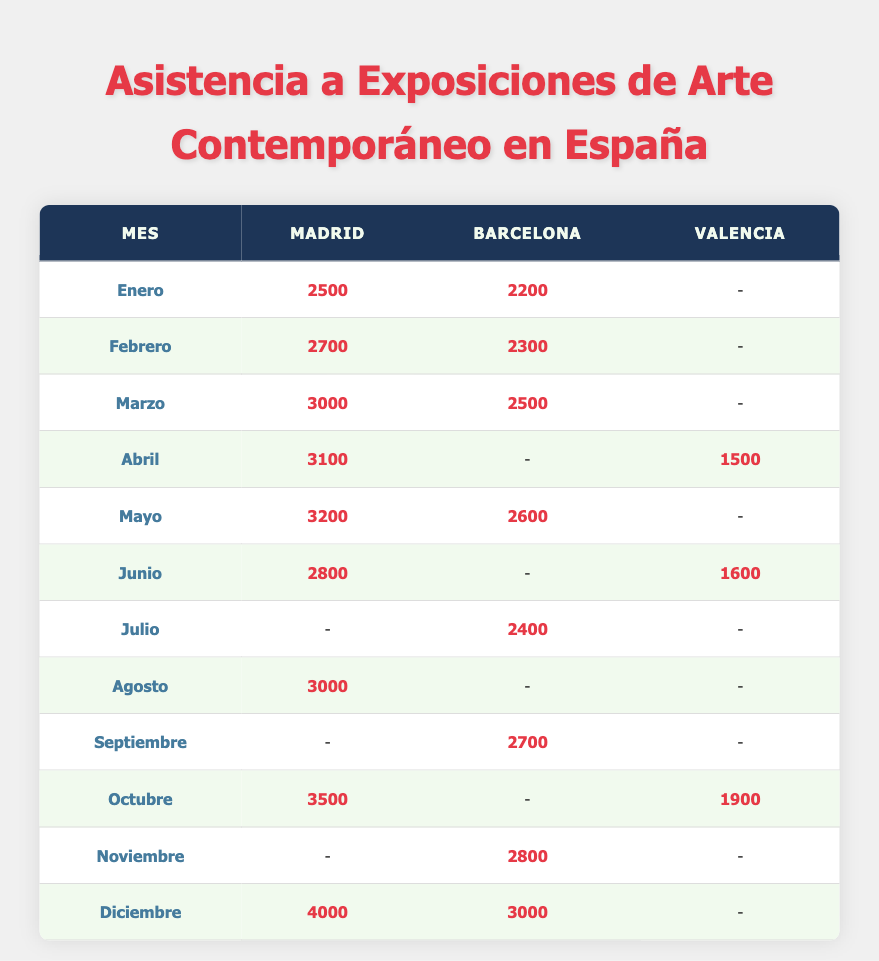What city had the highest attendance in December? In December, Madrid had an attendance of 4000, while Barcelona had 3000. Therefore, Madrid had the highest attendance.
Answer: Madrid Which month had the lowest attendance in Valencia? In Valencia, the lowest attendance was in April, with a count of 1500. Other months listed (June and October) also had attendance, but they were 1600 and 1900, respectively.
Answer: April What was the total attendance in Madrid from January to March? Adding the attendance figures for Madrid in January (2500), February (2700), and March (3000) gives a total of 2500 + 2700 + 3000 = 8200.
Answer: 8200 Was the attendance in Barcelona higher than in Valencia during any month? Yes, in the months of May and September, the attendance in Barcelona was higher than in Valencia since Valencia had no recorded attendance during those months.
Answer: Yes What is the average attendance across all cities in August? In August, only Madrid had attendance recorded with 3000, while Barcelona and Valencia had no attendance, so the average is simply 3000/1 = 3000.
Answer: 3000 Which city had more exhibition visitors, Barcelona or Madrid, in May? In May, Madrid had 3200 attendees, while Barcelona had 2600 attendees. Thus, Madrid had more visitors than Barcelona that month.
Answer: Madrid Which month saw the largest increase in Madrid's attendance compared to the previous month? Comparing the months from January to December, the largest increase occurred between November and December, where attendance rose from 3000 to 4000, an increase of 1000.
Answer: November to December Was there any month in which Valencia registered attendance while Barcelona did not? Yes, in April, Valencia had an attendance of 1500, while Barcelona did not have any recorded attendance during that month.
Answer: Yes What was the attendance in Barcelona over the summer months (June to August)? In June, there was no attendance recorded in Barcelona, in July it was 2400, and in August, there was no attendance either. Therefore, the attendance across the summer months is 2400.
Answer: 2400 